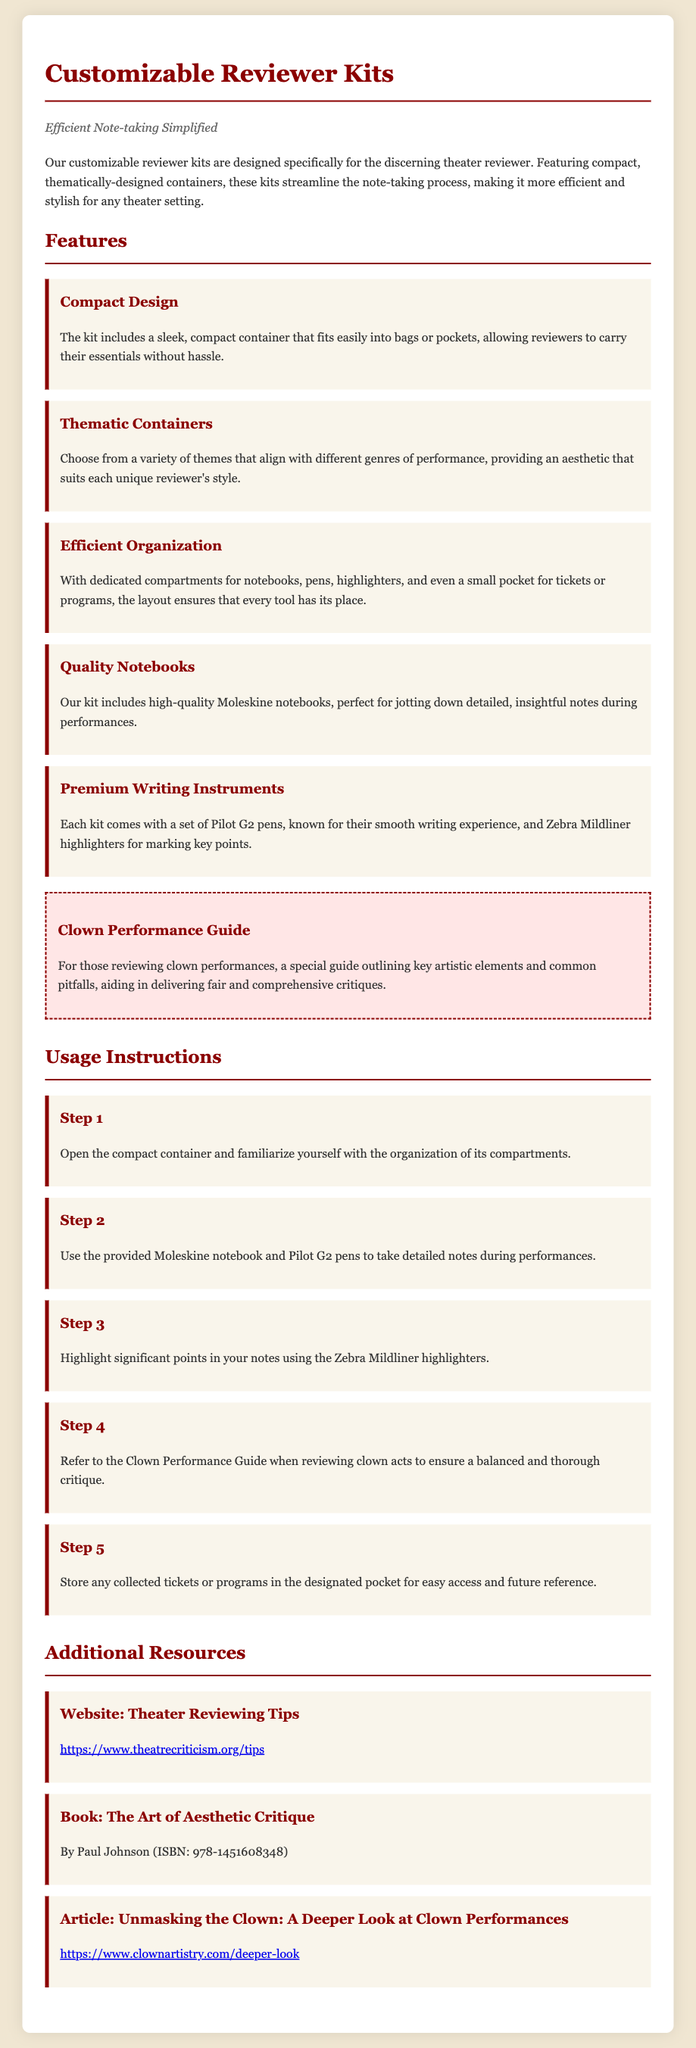what is the tagline of the product? The tagline summarizes the purpose of the kits, which is to simplify the note-taking process for reviewers.
Answer: Efficient Note-taking Simplified how many steps are in the usage instructions? The instructions consist of a sequence outlining how to effectively use the reviewer kit and detail five specific steps.
Answer: 5 what type of notebook is included in the kit? The document specifies the inclusion of a particular brand of notebook designed for note-taking during performances.
Answer: Moleskine notebooks which colors are used in the design of the document? The design includes specific color codes and styles particularly for headings and features which are primarily dark red and beige tones.
Answer: Dark red and beige what special guide is included for reviewing clown performances? The document mentions a particular section dedicated to guiding reviewers through the unique aspects of evaluating clown acts.
Answer: Clown Performance Guide how many thematic containers can reviewers choose from? The document mentions a variety of themes that align with different performance genres, implying multiple options for reviewers.
Answer: A variety of themes what is the purpose of the Zebra Mildliner highlighters included in the kit? The document specifies their function during note-taking, particularly in highlighting significant points.
Answer: Marking key points where can additional resources for theater reviewing be found? The document provides a specific website where reviewers can access further information and tips related to theater criticism.
Answer: https://www.theatrecriticism.org/tips 